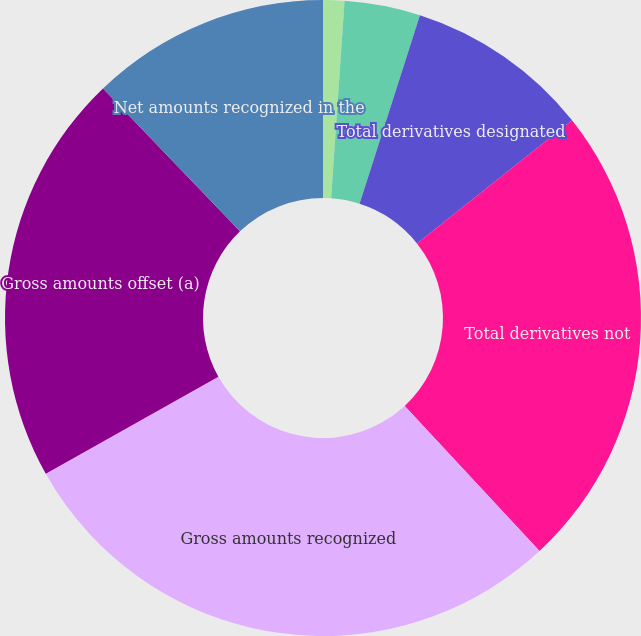Convert chart to OTSL. <chart><loc_0><loc_0><loc_500><loc_500><pie_chart><fcel>Other current assets/Other<fcel>Other deferred charges and<fcel>Total derivatives designated<fcel>Total derivatives not<fcel>Gross amounts recognized<fcel>Gross amounts offset (a)<fcel>Net amounts recognized in the<nl><fcel>1.08%<fcel>3.85%<fcel>9.39%<fcel>23.76%<fcel>28.77%<fcel>20.99%<fcel>12.16%<nl></chart> 